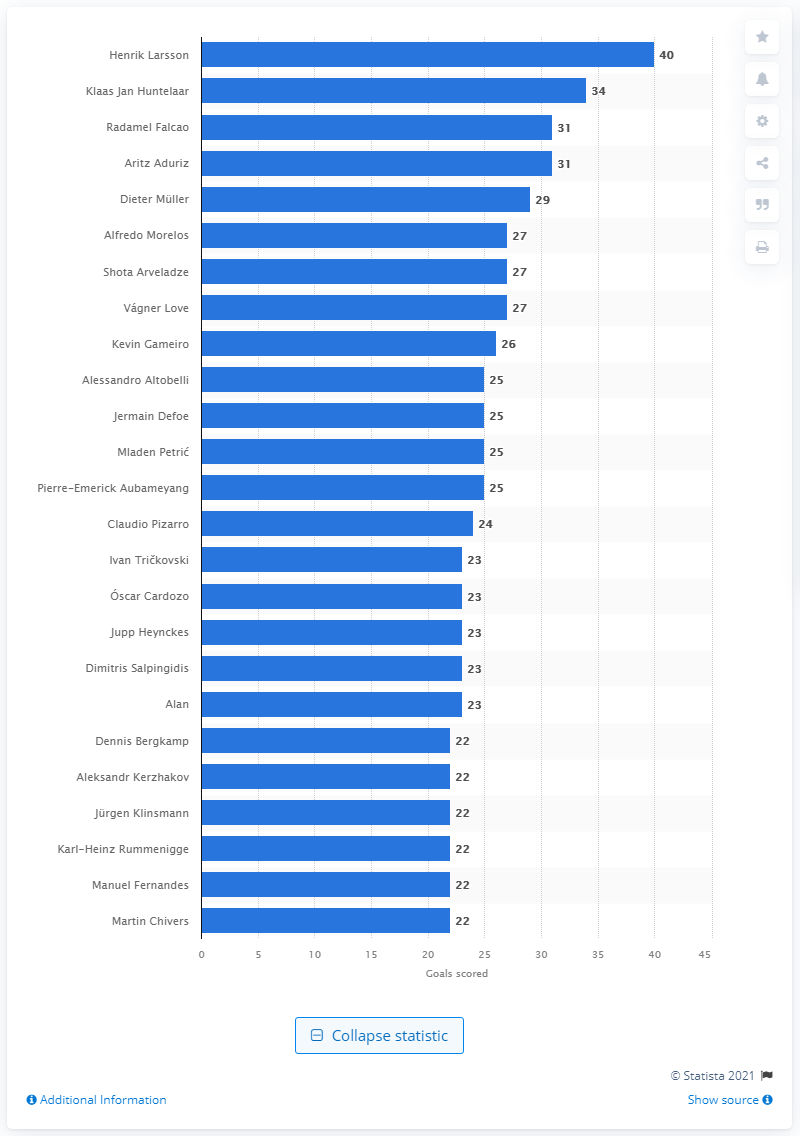Outline some significant characteristics in this image. Henrik Larsson is the European football player with the most goals scored in the UEFA Europa League. 